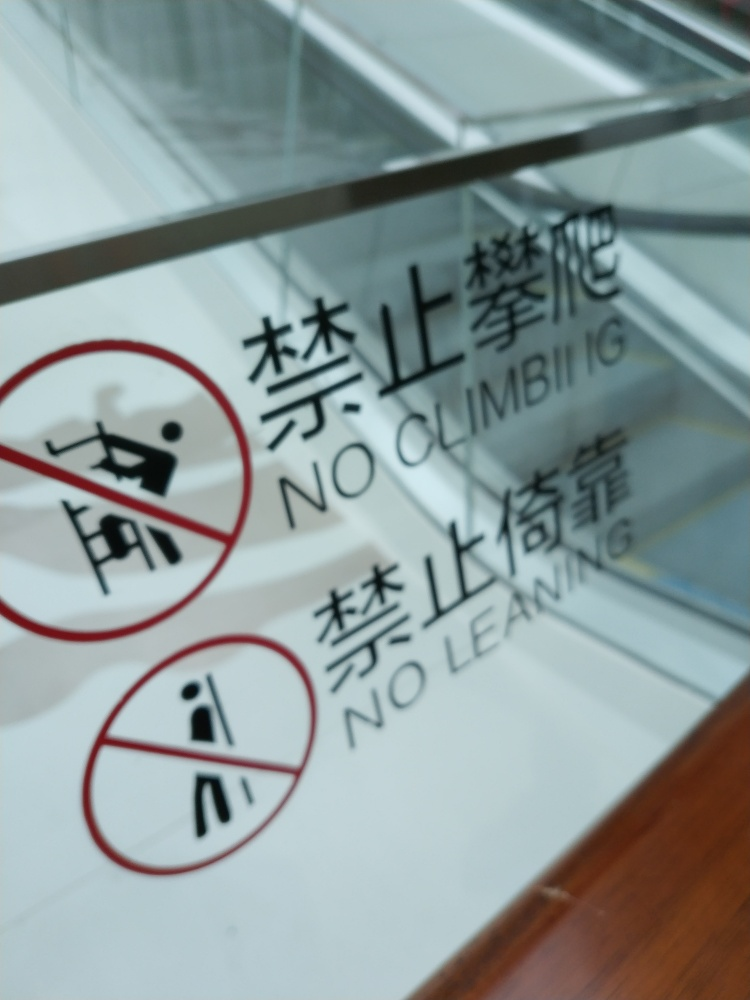Is the lighting strong in the image? Judging by the glare on the surface and the overall visibility of the text and symbols on the sign, the lighting in the image does appear to be relatively strong, although it might also be contributing to the blurriness of the photo. 